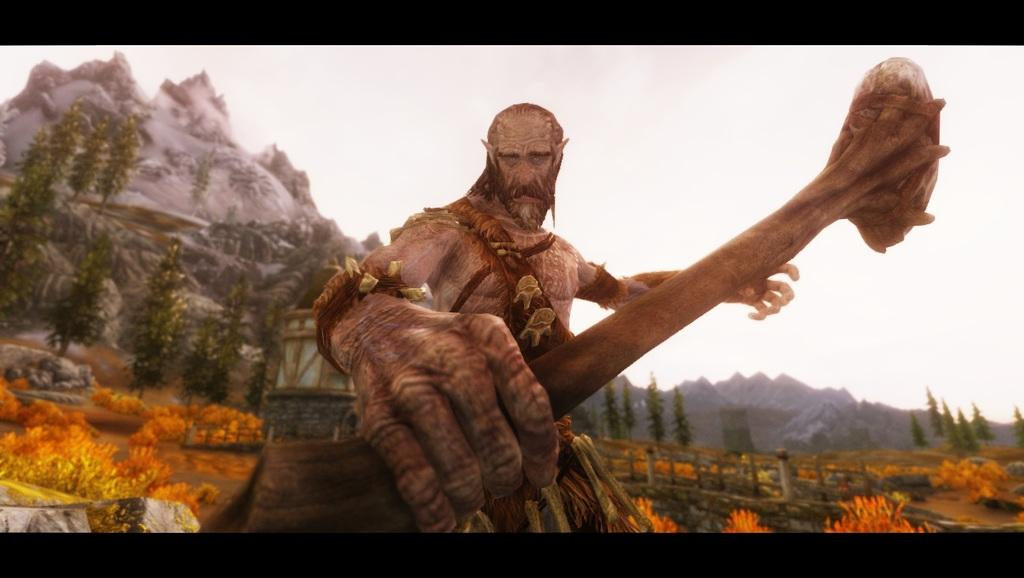What type of image is being described? The image is an animated picture. What is the person in the image holding? The person is holding a stick in the image. What can be seen in the background of the image? In the background of the image, there are mountains, trees, poles, stones, a railing, and the sky. What type of cloth is draped over the donkey in the image? There is no donkey present in the image, so there is no cloth draped over it. Can you describe the branch that the person is standing on in the image? There is no branch mentioned in the image, and the person is not standing on anything. 